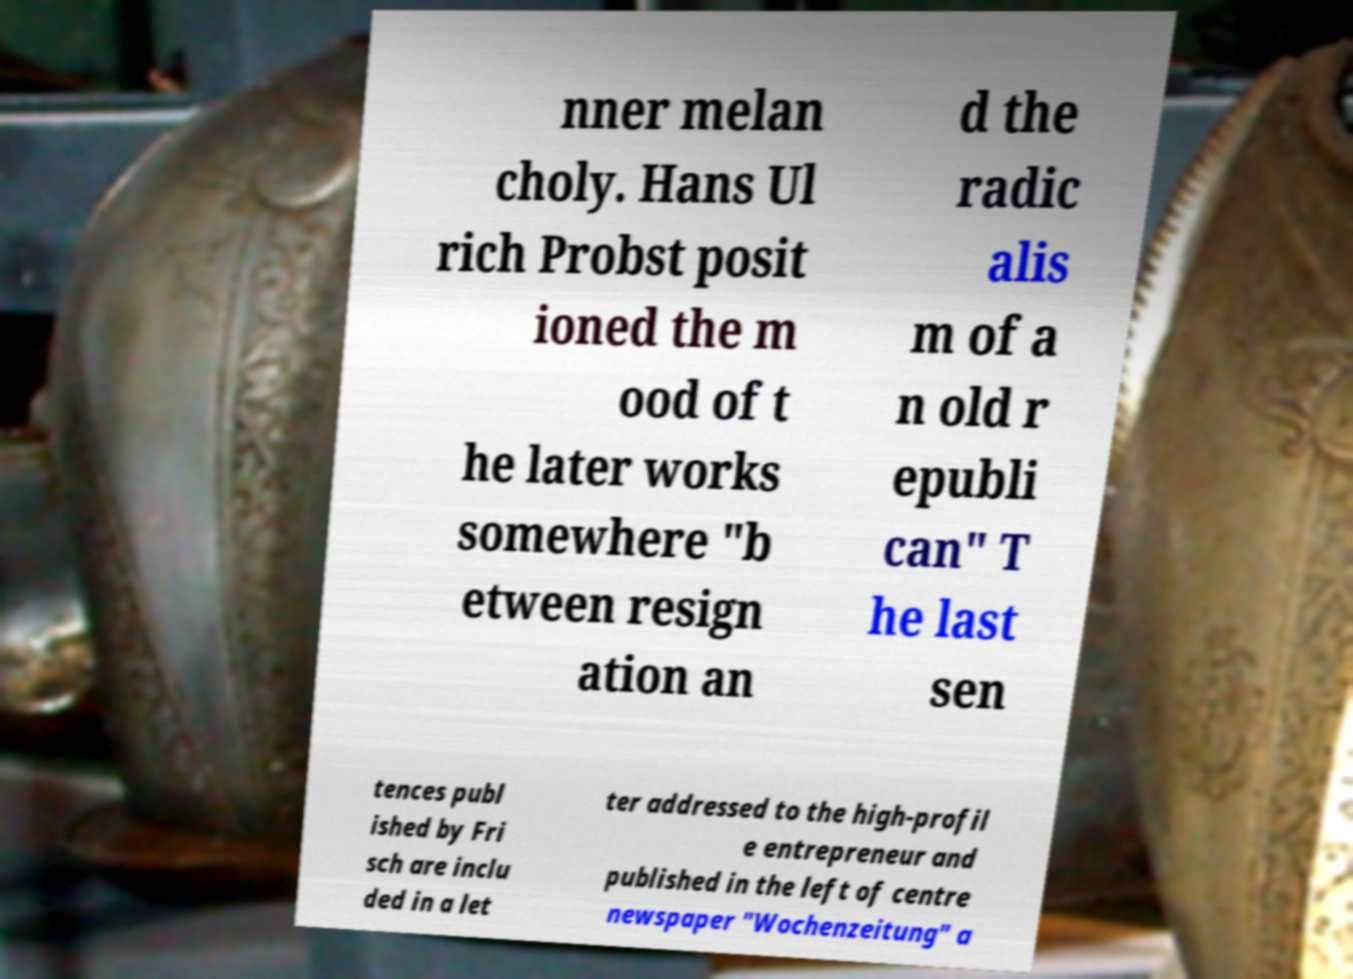Could you extract and type out the text from this image? nner melan choly. Hans Ul rich Probst posit ioned the m ood of t he later works somewhere "b etween resign ation an d the radic alis m of a n old r epubli can" T he last sen tences publ ished by Fri sch are inclu ded in a let ter addressed to the high-profil e entrepreneur and published in the left of centre newspaper "Wochenzeitung" a 